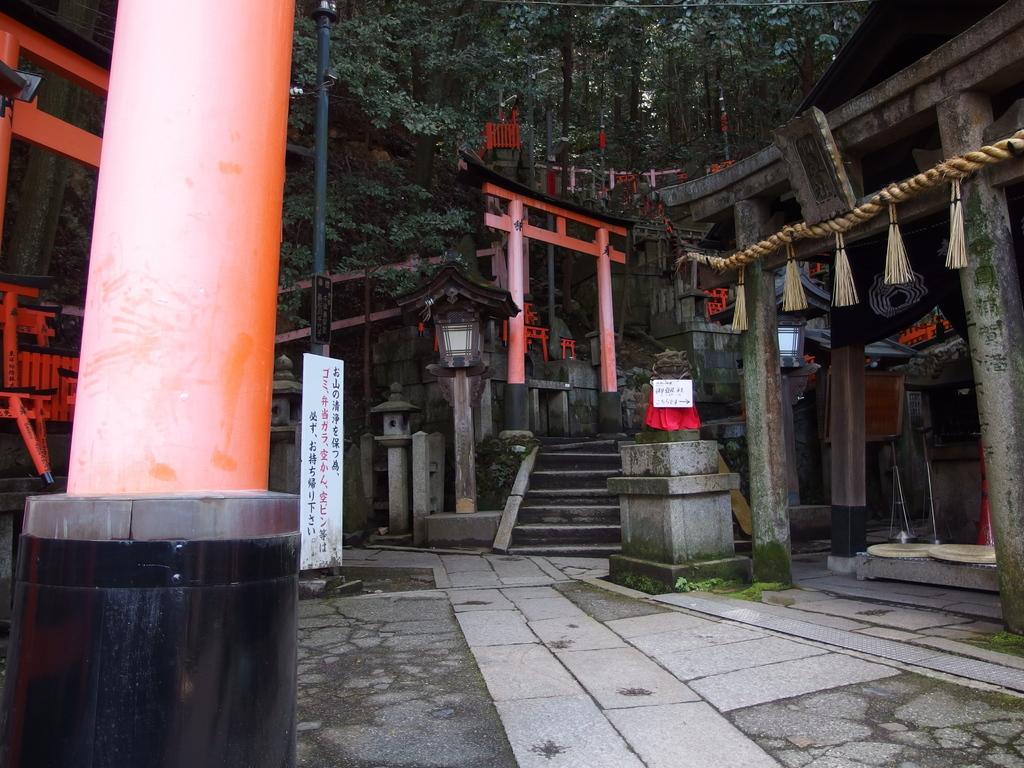In one or two sentences, can you explain what this image depicts? In this picture, there is an arch in the center which is in orange color. Before it, there are stairs. Towards the left, there is a pillar. Towards the right, there are pillars and roof tiles. In the background, there are trees. 